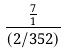<formula> <loc_0><loc_0><loc_500><loc_500>\frac { \frac { 7 } { 1 } } { ( 2 / 3 5 2 ) }</formula> 